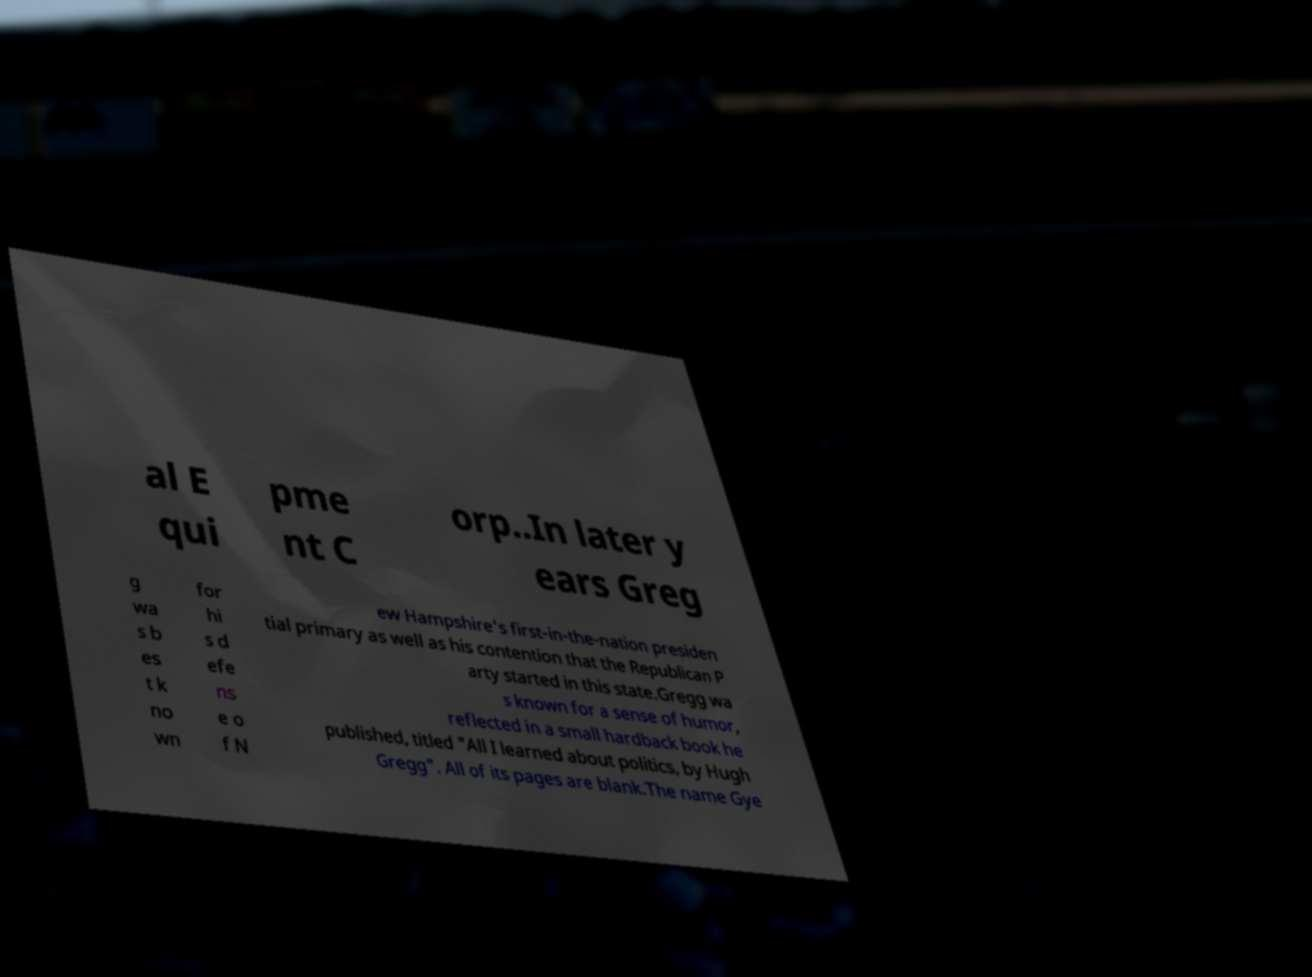Can you accurately transcribe the text from the provided image for me? al E qui pme nt C orp..In later y ears Greg g wa s b es t k no wn for hi s d efe ns e o f N ew Hampshire's first-in-the-nation presiden tial primary as well as his contention that the Republican P arty started in this state.Gregg wa s known for a sense of humor, reflected in a small hardback book he published, titled "All I learned about politics, by Hugh Gregg". All of its pages are blank.The name Gye 